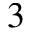<formula> <loc_0><loc_0><loc_500><loc_500>3</formula> 